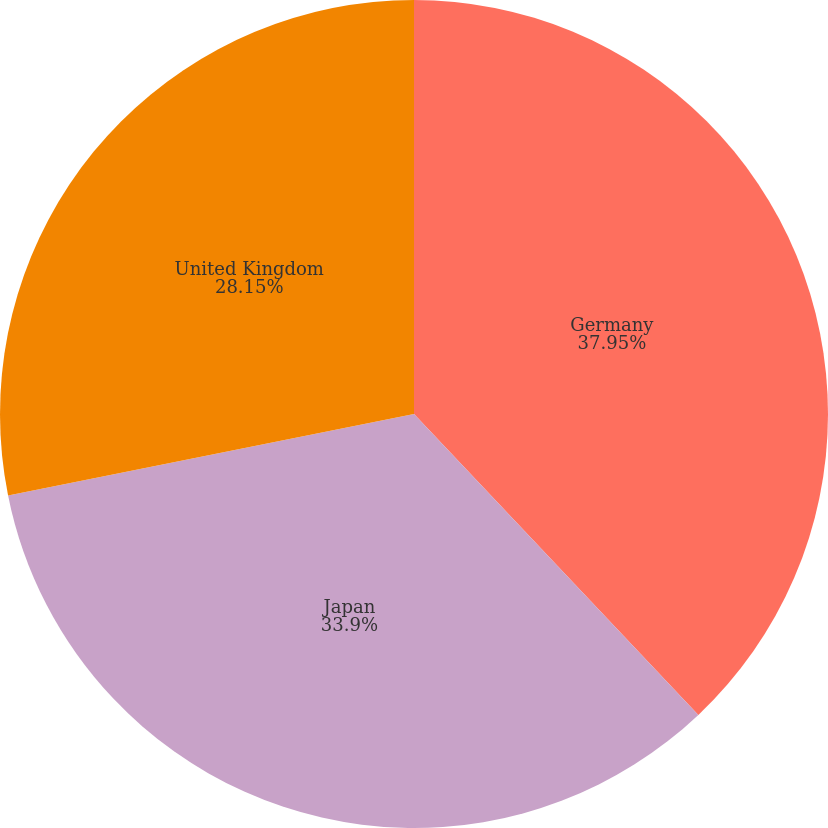Convert chart. <chart><loc_0><loc_0><loc_500><loc_500><pie_chart><fcel>Germany<fcel>Japan<fcel>United Kingdom<nl><fcel>37.95%<fcel>33.9%<fcel>28.15%<nl></chart> 